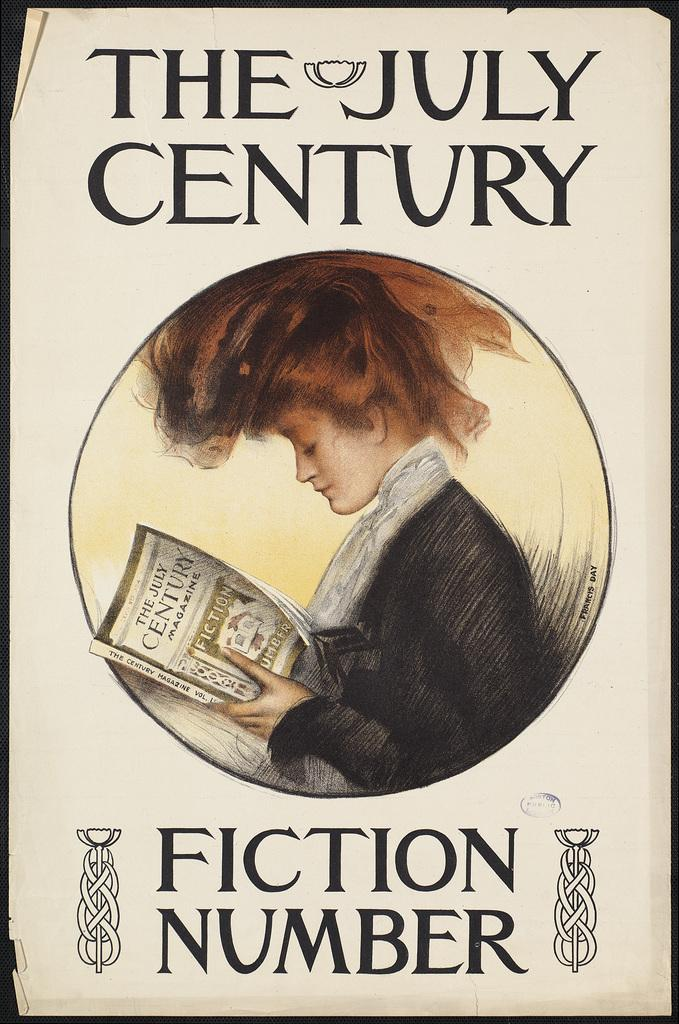Provide a one-sentence caption for the provided image. A fistion number book titled The July Century. 